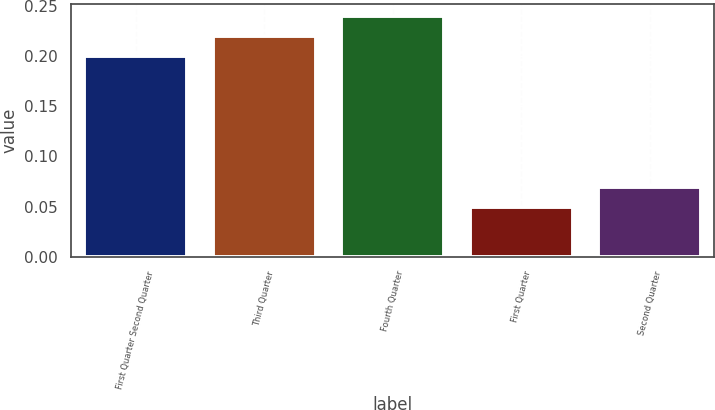Convert chart to OTSL. <chart><loc_0><loc_0><loc_500><loc_500><bar_chart><fcel>First Quarter Second Quarter<fcel>Third Quarter<fcel>Fourth Quarter<fcel>First Quarter<fcel>Second Quarter<nl><fcel>0.2<fcel>0.22<fcel>0.24<fcel>0.05<fcel>0.07<nl></chart> 